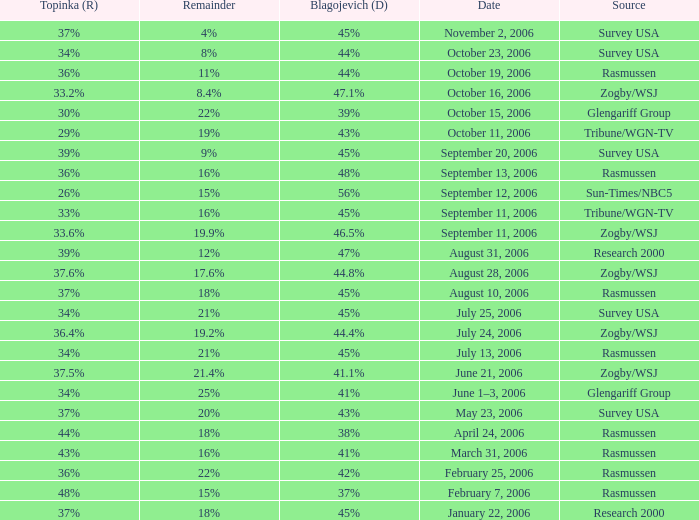Which Date has a Remainder of 20%? May 23, 2006. 